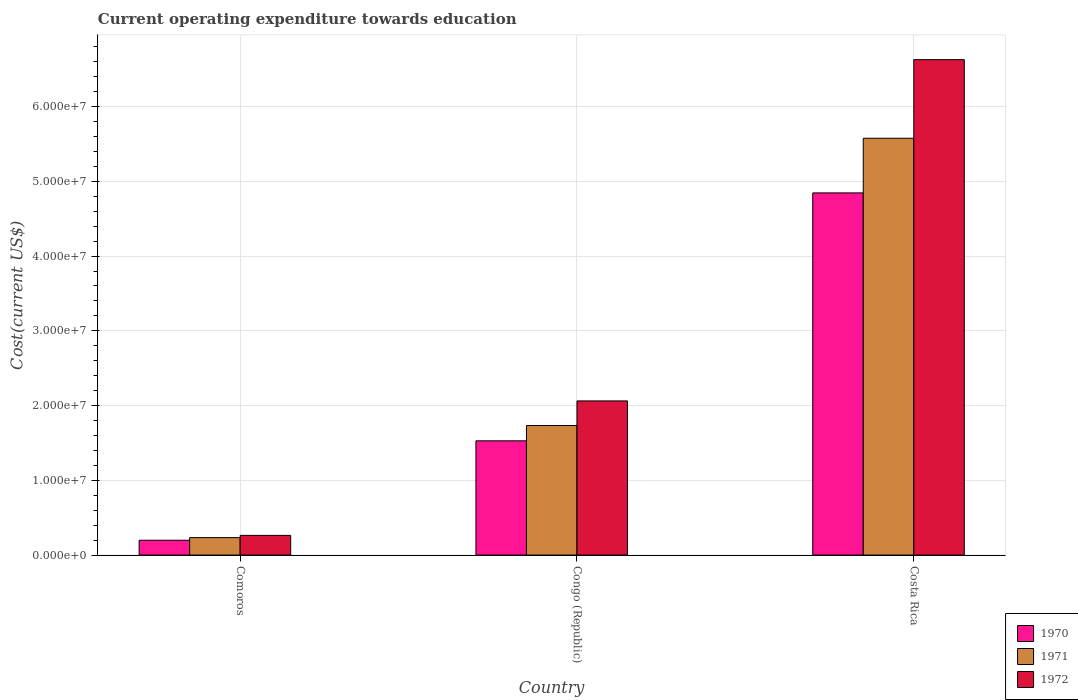How many different coloured bars are there?
Your answer should be compact. 3. How many groups of bars are there?
Offer a very short reply. 3. How many bars are there on the 2nd tick from the left?
Make the answer very short. 3. How many bars are there on the 1st tick from the right?
Your answer should be compact. 3. What is the expenditure towards education in 1972 in Costa Rica?
Offer a terse response. 6.63e+07. Across all countries, what is the maximum expenditure towards education in 1972?
Provide a succinct answer. 6.63e+07. Across all countries, what is the minimum expenditure towards education in 1970?
Ensure brevity in your answer.  1.98e+06. In which country was the expenditure towards education in 1972 maximum?
Offer a very short reply. Costa Rica. In which country was the expenditure towards education in 1972 minimum?
Your answer should be very brief. Comoros. What is the total expenditure towards education in 1971 in the graph?
Offer a very short reply. 7.54e+07. What is the difference between the expenditure towards education in 1970 in Congo (Republic) and that in Costa Rica?
Provide a succinct answer. -3.32e+07. What is the difference between the expenditure towards education in 1971 in Comoros and the expenditure towards education in 1972 in Congo (Republic)?
Make the answer very short. -1.83e+07. What is the average expenditure towards education in 1970 per country?
Provide a short and direct response. 2.19e+07. What is the difference between the expenditure towards education of/in 1972 and expenditure towards education of/in 1970 in Comoros?
Your answer should be very brief. 6.53e+05. What is the ratio of the expenditure towards education in 1970 in Comoros to that in Costa Rica?
Keep it short and to the point. 0.04. Is the expenditure towards education in 1970 in Comoros less than that in Costa Rica?
Offer a very short reply. Yes. Is the difference between the expenditure towards education in 1972 in Congo (Republic) and Costa Rica greater than the difference between the expenditure towards education in 1970 in Congo (Republic) and Costa Rica?
Provide a short and direct response. No. What is the difference between the highest and the second highest expenditure towards education in 1970?
Your answer should be compact. 4.65e+07. What is the difference between the highest and the lowest expenditure towards education in 1971?
Make the answer very short. 5.34e+07. In how many countries, is the expenditure towards education in 1972 greater than the average expenditure towards education in 1972 taken over all countries?
Keep it short and to the point. 1. What does the 2nd bar from the left in Costa Rica represents?
Give a very brief answer. 1971. What does the 1st bar from the right in Costa Rica represents?
Make the answer very short. 1972. Is it the case that in every country, the sum of the expenditure towards education in 1970 and expenditure towards education in 1972 is greater than the expenditure towards education in 1971?
Provide a succinct answer. Yes. Are all the bars in the graph horizontal?
Keep it short and to the point. No. Are the values on the major ticks of Y-axis written in scientific E-notation?
Provide a succinct answer. Yes. Does the graph contain any zero values?
Ensure brevity in your answer.  No. Does the graph contain grids?
Offer a very short reply. Yes. Where does the legend appear in the graph?
Keep it short and to the point. Bottom right. What is the title of the graph?
Offer a terse response. Current operating expenditure towards education. What is the label or title of the Y-axis?
Your answer should be very brief. Cost(current US$). What is the Cost(current US$) in 1970 in Comoros?
Provide a short and direct response. 1.98e+06. What is the Cost(current US$) of 1971 in Comoros?
Provide a short and direct response. 2.34e+06. What is the Cost(current US$) of 1972 in Comoros?
Your response must be concise. 2.64e+06. What is the Cost(current US$) in 1970 in Congo (Republic)?
Make the answer very short. 1.53e+07. What is the Cost(current US$) in 1971 in Congo (Republic)?
Your answer should be very brief. 1.73e+07. What is the Cost(current US$) of 1972 in Congo (Republic)?
Make the answer very short. 2.06e+07. What is the Cost(current US$) of 1970 in Costa Rica?
Your response must be concise. 4.85e+07. What is the Cost(current US$) in 1971 in Costa Rica?
Your answer should be very brief. 5.58e+07. What is the Cost(current US$) in 1972 in Costa Rica?
Make the answer very short. 6.63e+07. Across all countries, what is the maximum Cost(current US$) in 1970?
Give a very brief answer. 4.85e+07. Across all countries, what is the maximum Cost(current US$) of 1971?
Ensure brevity in your answer.  5.58e+07. Across all countries, what is the maximum Cost(current US$) of 1972?
Keep it short and to the point. 6.63e+07. Across all countries, what is the minimum Cost(current US$) in 1970?
Make the answer very short. 1.98e+06. Across all countries, what is the minimum Cost(current US$) in 1971?
Give a very brief answer. 2.34e+06. Across all countries, what is the minimum Cost(current US$) in 1972?
Your answer should be compact. 2.64e+06. What is the total Cost(current US$) in 1970 in the graph?
Your answer should be compact. 6.57e+07. What is the total Cost(current US$) of 1971 in the graph?
Keep it short and to the point. 7.54e+07. What is the total Cost(current US$) in 1972 in the graph?
Your answer should be compact. 8.95e+07. What is the difference between the Cost(current US$) in 1970 in Comoros and that in Congo (Republic)?
Give a very brief answer. -1.33e+07. What is the difference between the Cost(current US$) in 1971 in Comoros and that in Congo (Republic)?
Offer a very short reply. -1.50e+07. What is the difference between the Cost(current US$) of 1972 in Comoros and that in Congo (Republic)?
Your answer should be compact. -1.80e+07. What is the difference between the Cost(current US$) of 1970 in Comoros and that in Costa Rica?
Provide a short and direct response. -4.65e+07. What is the difference between the Cost(current US$) in 1971 in Comoros and that in Costa Rica?
Your response must be concise. -5.34e+07. What is the difference between the Cost(current US$) of 1972 in Comoros and that in Costa Rica?
Provide a short and direct response. -6.36e+07. What is the difference between the Cost(current US$) in 1970 in Congo (Republic) and that in Costa Rica?
Offer a terse response. -3.32e+07. What is the difference between the Cost(current US$) of 1971 in Congo (Republic) and that in Costa Rica?
Provide a succinct answer. -3.84e+07. What is the difference between the Cost(current US$) in 1972 in Congo (Republic) and that in Costa Rica?
Provide a succinct answer. -4.57e+07. What is the difference between the Cost(current US$) of 1970 in Comoros and the Cost(current US$) of 1971 in Congo (Republic)?
Make the answer very short. -1.53e+07. What is the difference between the Cost(current US$) in 1970 in Comoros and the Cost(current US$) in 1972 in Congo (Republic)?
Give a very brief answer. -1.86e+07. What is the difference between the Cost(current US$) of 1971 in Comoros and the Cost(current US$) of 1972 in Congo (Republic)?
Provide a short and direct response. -1.83e+07. What is the difference between the Cost(current US$) in 1970 in Comoros and the Cost(current US$) in 1971 in Costa Rica?
Give a very brief answer. -5.38e+07. What is the difference between the Cost(current US$) of 1970 in Comoros and the Cost(current US$) of 1972 in Costa Rica?
Ensure brevity in your answer.  -6.43e+07. What is the difference between the Cost(current US$) of 1971 in Comoros and the Cost(current US$) of 1972 in Costa Rica?
Keep it short and to the point. -6.39e+07. What is the difference between the Cost(current US$) of 1970 in Congo (Republic) and the Cost(current US$) of 1971 in Costa Rica?
Give a very brief answer. -4.05e+07. What is the difference between the Cost(current US$) of 1970 in Congo (Republic) and the Cost(current US$) of 1972 in Costa Rica?
Provide a succinct answer. -5.10e+07. What is the difference between the Cost(current US$) of 1971 in Congo (Republic) and the Cost(current US$) of 1972 in Costa Rica?
Your answer should be very brief. -4.89e+07. What is the average Cost(current US$) in 1970 per country?
Make the answer very short. 2.19e+07. What is the average Cost(current US$) in 1971 per country?
Offer a terse response. 2.51e+07. What is the average Cost(current US$) in 1972 per country?
Provide a succinct answer. 2.98e+07. What is the difference between the Cost(current US$) in 1970 and Cost(current US$) in 1971 in Comoros?
Your answer should be compact. -3.52e+05. What is the difference between the Cost(current US$) of 1970 and Cost(current US$) of 1972 in Comoros?
Your answer should be very brief. -6.53e+05. What is the difference between the Cost(current US$) of 1971 and Cost(current US$) of 1972 in Comoros?
Ensure brevity in your answer.  -3.01e+05. What is the difference between the Cost(current US$) of 1970 and Cost(current US$) of 1971 in Congo (Republic)?
Provide a short and direct response. -2.05e+06. What is the difference between the Cost(current US$) in 1970 and Cost(current US$) in 1972 in Congo (Republic)?
Keep it short and to the point. -5.34e+06. What is the difference between the Cost(current US$) in 1971 and Cost(current US$) in 1972 in Congo (Republic)?
Provide a succinct answer. -3.29e+06. What is the difference between the Cost(current US$) in 1970 and Cost(current US$) in 1971 in Costa Rica?
Provide a succinct answer. -7.31e+06. What is the difference between the Cost(current US$) in 1970 and Cost(current US$) in 1972 in Costa Rica?
Offer a terse response. -1.78e+07. What is the difference between the Cost(current US$) in 1971 and Cost(current US$) in 1972 in Costa Rica?
Your answer should be compact. -1.05e+07. What is the ratio of the Cost(current US$) of 1970 in Comoros to that in Congo (Republic)?
Give a very brief answer. 0.13. What is the ratio of the Cost(current US$) of 1971 in Comoros to that in Congo (Republic)?
Provide a succinct answer. 0.13. What is the ratio of the Cost(current US$) in 1972 in Comoros to that in Congo (Republic)?
Offer a very short reply. 0.13. What is the ratio of the Cost(current US$) of 1970 in Comoros to that in Costa Rica?
Offer a terse response. 0.04. What is the ratio of the Cost(current US$) in 1971 in Comoros to that in Costa Rica?
Your response must be concise. 0.04. What is the ratio of the Cost(current US$) in 1972 in Comoros to that in Costa Rica?
Make the answer very short. 0.04. What is the ratio of the Cost(current US$) of 1970 in Congo (Republic) to that in Costa Rica?
Make the answer very short. 0.32. What is the ratio of the Cost(current US$) in 1971 in Congo (Republic) to that in Costa Rica?
Keep it short and to the point. 0.31. What is the ratio of the Cost(current US$) in 1972 in Congo (Republic) to that in Costa Rica?
Your answer should be compact. 0.31. What is the difference between the highest and the second highest Cost(current US$) of 1970?
Provide a short and direct response. 3.32e+07. What is the difference between the highest and the second highest Cost(current US$) of 1971?
Your answer should be very brief. 3.84e+07. What is the difference between the highest and the second highest Cost(current US$) in 1972?
Your response must be concise. 4.57e+07. What is the difference between the highest and the lowest Cost(current US$) in 1970?
Offer a terse response. 4.65e+07. What is the difference between the highest and the lowest Cost(current US$) of 1971?
Make the answer very short. 5.34e+07. What is the difference between the highest and the lowest Cost(current US$) in 1972?
Your answer should be compact. 6.36e+07. 